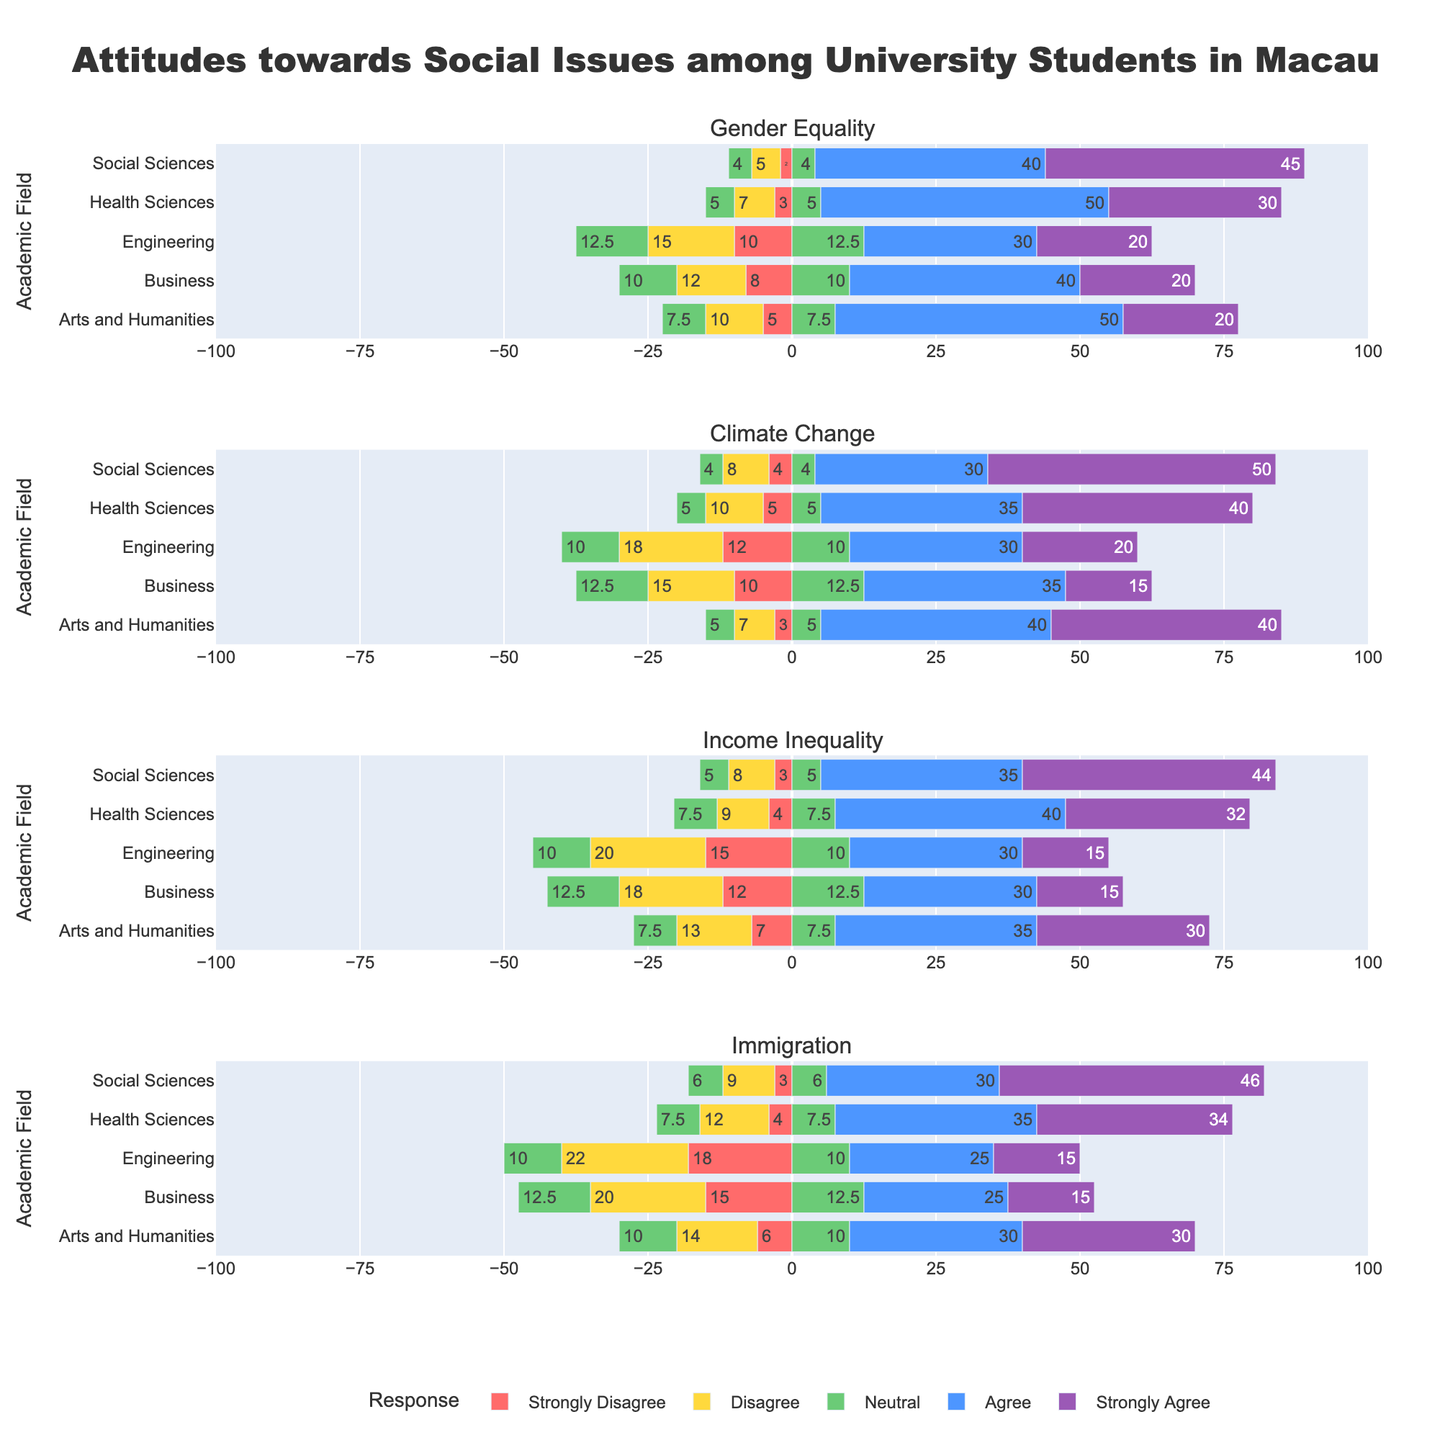Which academic field shows the highest percentage of students agreeing (including both "Agree" and "Strongly Agree") with gender equality? To find this, look at the bars for "Agree" and "Strongly Agree" under Gender Equality for each academic field. Summing these values for each field, we see: Arts and Humanities (50+20=70), Business (40+20=60), Engineering (30+20=50), Health Sciences (50+30=80), Social Sciences (40+45=85). The Social Sciences field shows the highest combined percentage of 85.
Answer: Social Sciences Which academic field indicates the largest disagreement (including both "Strongly Disagree" and "Disagree") concerning immigration? Check the bars labeled "Strongly Disagree" and "Disagree" under Immigration for each field. Summing these values, we get: Arts and Humanities (6+14=20), Business (15+20=35), Engineering (18+22=40), Health Sciences (4+12=16), Social Sciences (3+9=12). Engineering has the highest combined disagreement at 40.
Answer: Engineering How does the support for climate change (Agree and Strongly Agree) among Health Sciences students compare with students in the Business field? For Health Sciences, the support is 35+40=75. For Business, it is 35+15=50. Comparing these, Health Sciences (75) shows higher support than Business (50).
Answer: Health Sciences shows higher support What is the average percentage of Neutral responses across all academic fields for income inequality? To compute the average, sum the Neutral percentages for all fields: Arts and Humanities (15), Business (25), Engineering (20), Health Sciences (15), Social Sciences (10). The total is 85. There are 5 fields, so the average is 85/5=17.
Answer: 17 Compare the Strongly Disagree responses for climate change among Engineering and Social Sciences students. Which field has more, and by how much? Engineering has 12% Strongly Disagree, Social Sciences has 4%. The difference is 12-4=8%. Engineering has 8% more Strongly Disagree responses than Social Sciences.
Answer: Engineering by 8% What is the total percentage of students in Health Sciences that either agree or are neutral about immigration? For Health Sciences, Neutral is 15, Agree is 35, and Strongly Agree is 34. Adding these percentages: 15+35+34=84.
Answer: 84 Which academic field has the most students strongly agreeing with income inequality being a problem? Looking at the Strongly Agree bar under Income Inequality, we see the percentages are: Arts and Humanities (30), Business (15), Engineering (15), Health Sciences (32), Social Sciences (44). Social Sciences has the highest percentage at 44.
Answer: Social Sciences For each academic field, what is the combined percentage of students that disagree (Strongly Disagree plus Disagree) with gender equality? By field: Arts and Humanities (5+10=15), Business (8+12=20), Engineering (10+15=25), Health Sciences (3+7=10), Social Sciences (2+5=7).
Answer: 15 (Arts & Humanities), 20 (Business), 25 (Engineering), 10 (Health Sciences), 7 (Social Sciences) Which issue shows the greatest level of Neutral response among all academic fields? Summing the Neutral responses for each issue across all fields: Gender Equality (15+20+25+10+8=78), Climate Change (10+25+20+10+8=73), Income Inequality (15+25+20+15+10=85), Immigration (20+25+20+15+12=92). Immigration has the highest total Neutral response at 92.
Answer: Immigration What is the percentage difference in Strongly Agree responses to climate change between Arts and Humanities and Business students? Arts and Humanities has 40% Strongly Agree, Business has 15%. The difference is 40-15=25%.
Answer: 25% 